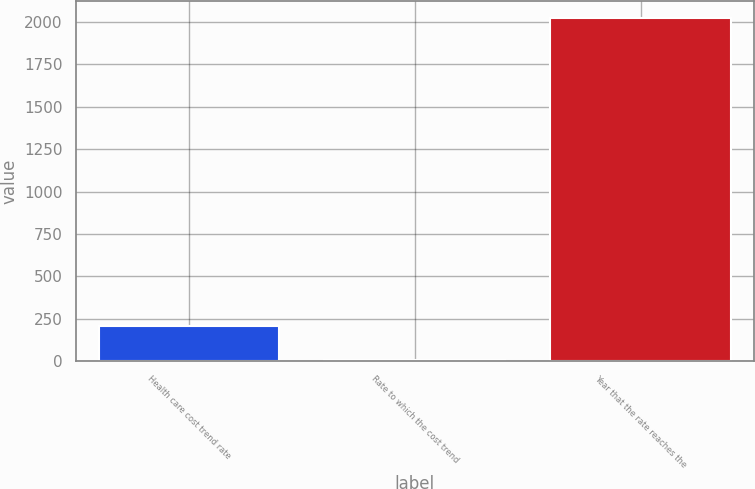Convert chart. <chart><loc_0><loc_0><loc_500><loc_500><bar_chart><fcel>Health care cost trend rate<fcel>Rate to which the cost trend<fcel>Year that the rate reaches the<nl><fcel>206.15<fcel>4.5<fcel>2021<nl></chart> 